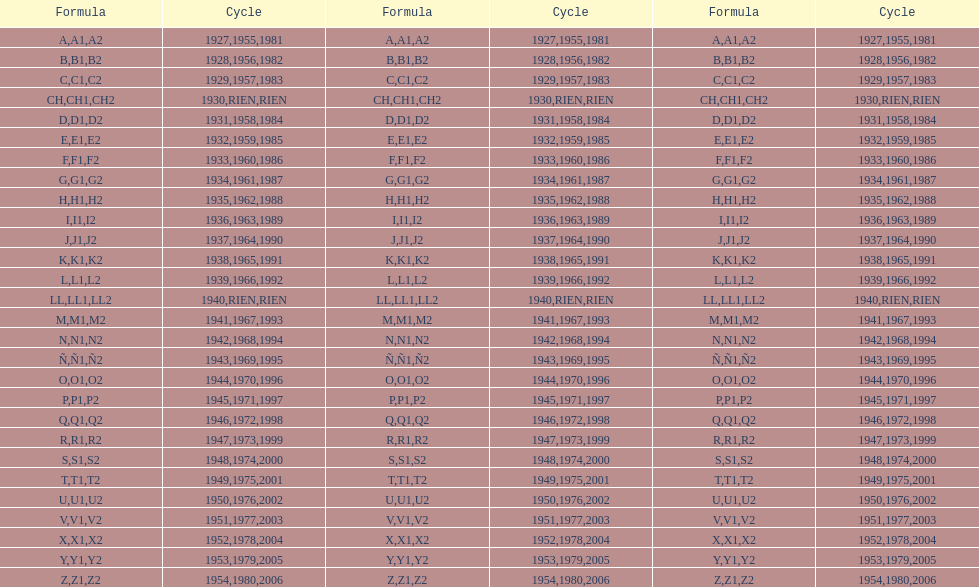Number of codes containing a 2? 28. 